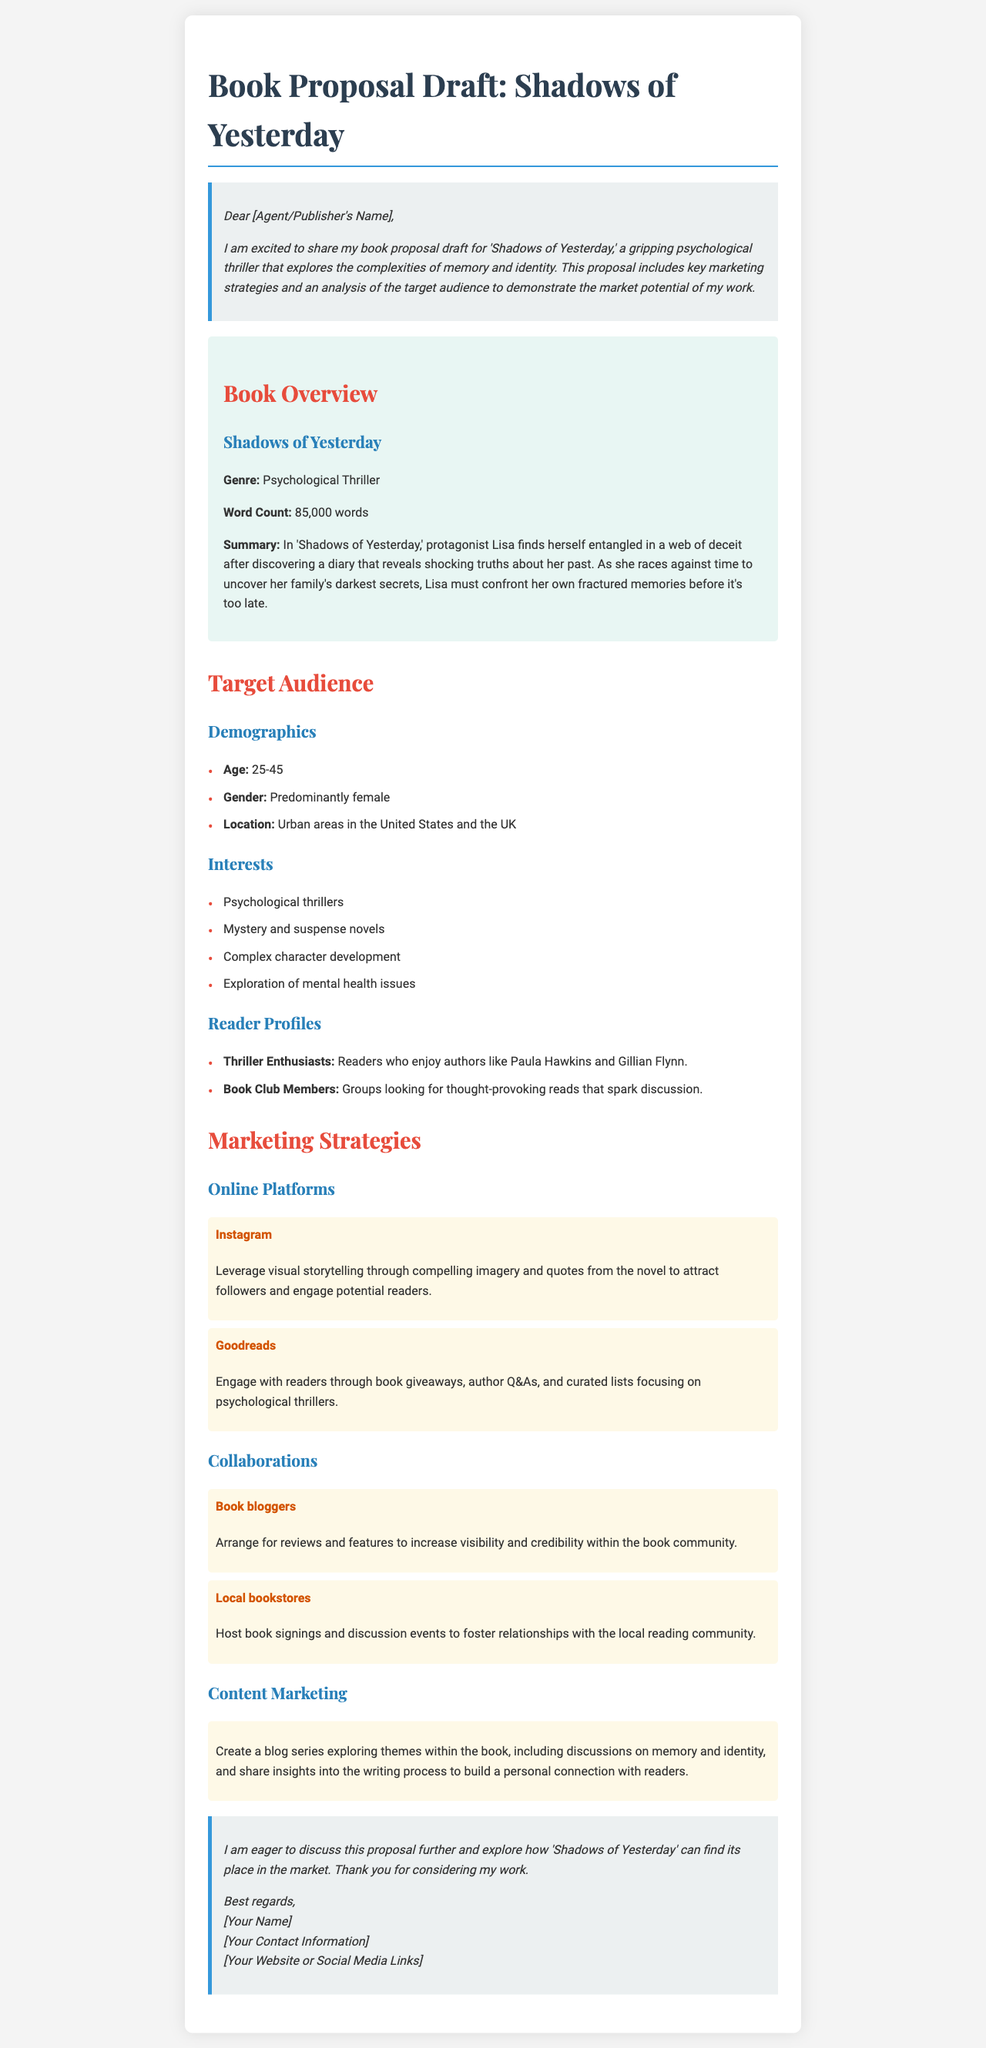What is the title of the book? The title of the book is prominently mentioned in the header of the document.
Answer: Shadows of Yesterday What is the genre of the book? The genre is specified in the book overview section.
Answer: Psychological Thriller What is the word count of the book? The word count is listed under the book overview section.
Answer: 85,000 words Who is the protagonist? The protagonist's name is provided in the summary of the book.
Answer: Lisa What is the target age demographic? The age demographic is mentioned in the target audience section.
Answer: 25-45 Which online platform is suggested for visual storytelling? The marketing strategies section indicates specific platforms for marketing.
Answer: Instagram Which authors are mentioned as similar to the book? Reader profiles in the target audience section list similar authors.
Answer: Paula Hawkins and Gillian Flynn What type of events are suggested for local bookstores? The marketing strategies section suggests certain activities.
Answer: Book signings and discussion events What is the main theme explored in the blog series? The content marketing section discusses themes related to the book.
Answer: Memory and identity 